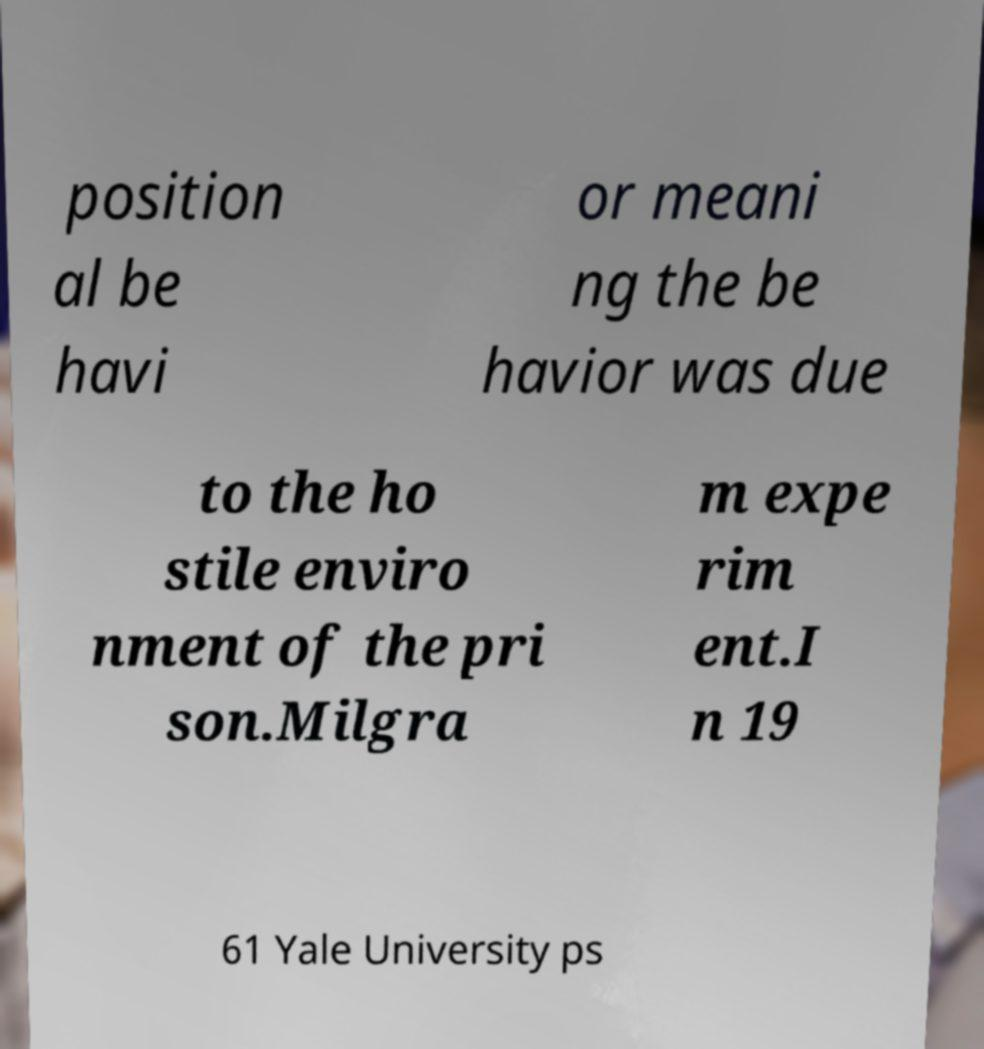Please identify and transcribe the text found in this image. position al be havi or meani ng the be havior was due to the ho stile enviro nment of the pri son.Milgra m expe rim ent.I n 19 61 Yale University ps 